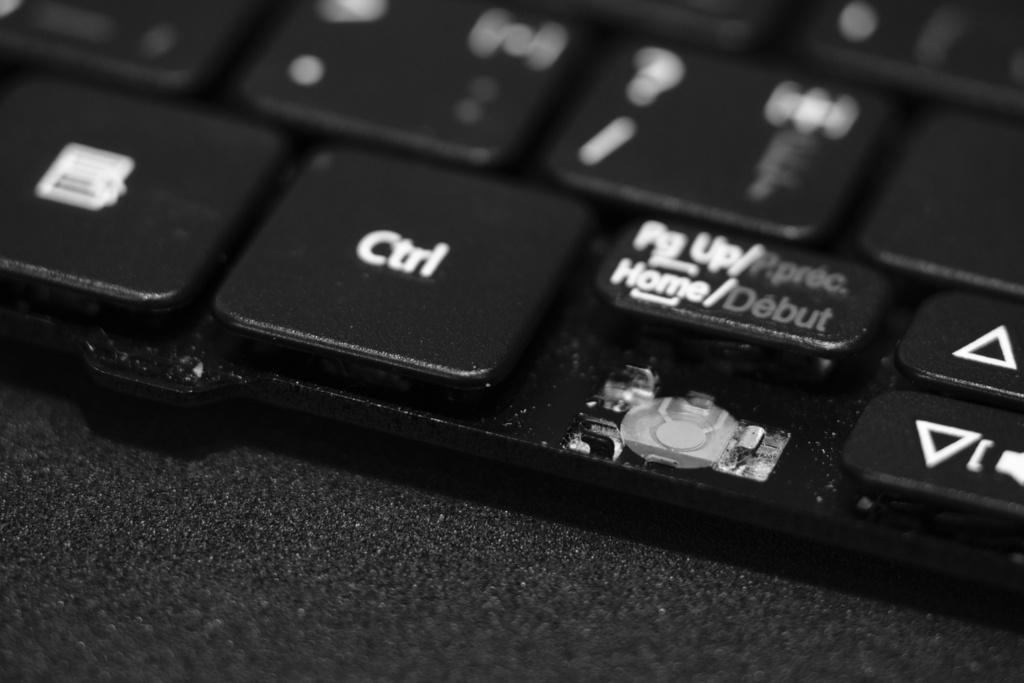What is one of the keys on the keyboard?
Your response must be concise. Ctrl. What is the text on the second to left key?
Provide a succinct answer. Ctrl. 